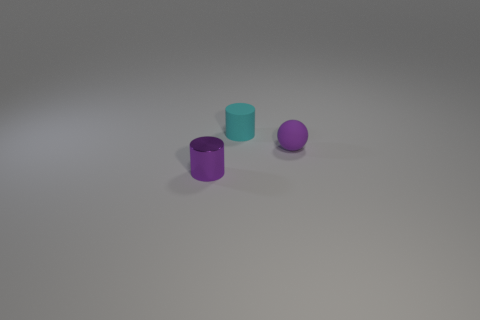Subtract all cyan cylinders. How many cylinders are left? 1 Subtract all cylinders. How many objects are left? 1 Subtract all brown spheres. Subtract all gray cylinders. How many spheres are left? 1 Subtract all yellow balls. How many cyan cylinders are left? 1 Subtract all purple matte spheres. Subtract all cyan cylinders. How many objects are left? 1 Add 2 purple cylinders. How many purple cylinders are left? 3 Add 3 purple shiny cylinders. How many purple shiny cylinders exist? 4 Add 1 tiny purple rubber objects. How many objects exist? 4 Subtract 0 cyan spheres. How many objects are left? 3 